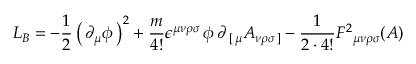<formula> <loc_0><loc_0><loc_500><loc_500>L _ { B } = - { \frac { 1 } { 2 } } \left ( \, \partial _ { \mu } \phi \, \right ) ^ { 2 } + { \frac { m } { 4 ! } } \epsilon ^ { \mu \nu \rho \sigma } \, \phi \, \partial _ { \, [ \, \mu } A _ { \nu \rho \sigma \, ] } - { \frac { 1 } { 2 \cdot 4 ! } } F ^ { 2 _ { \mu \nu \rho \sigma } ( A )</formula> 